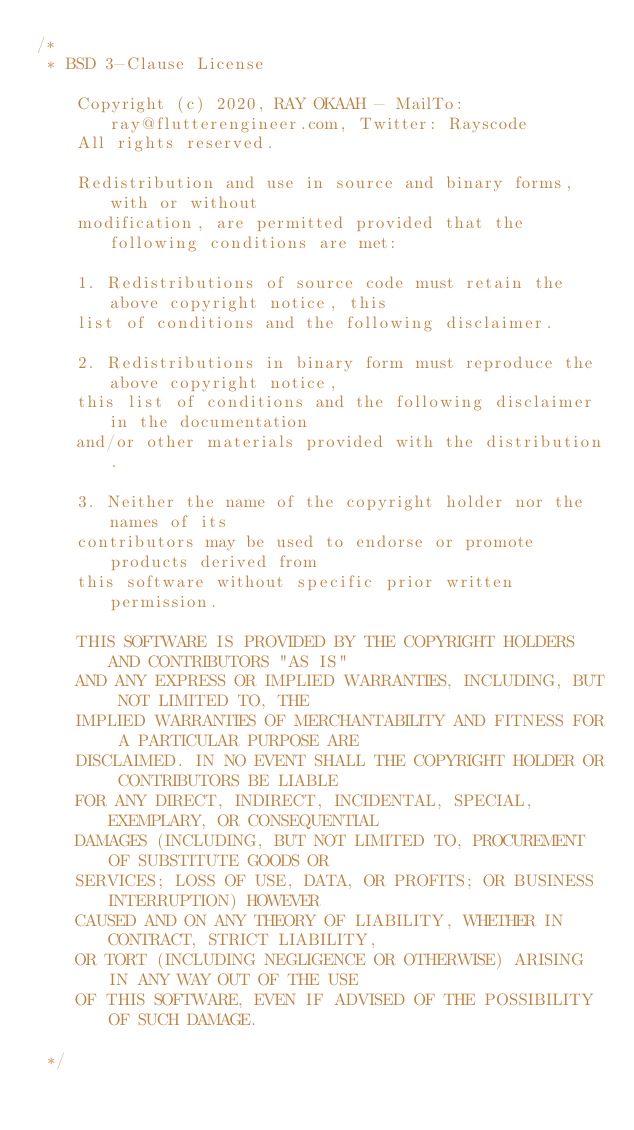<code> <loc_0><loc_0><loc_500><loc_500><_Dart_>/*
 * BSD 3-Clause License

    Copyright (c) 2020, RAY OKAAH - MailTo: ray@flutterengineer.com, Twitter: Rayscode
    All rights reserved.

    Redistribution and use in source and binary forms, with or without
    modification, are permitted provided that the following conditions are met:

    1. Redistributions of source code must retain the above copyright notice, this
    list of conditions and the following disclaimer.

    2. Redistributions in binary form must reproduce the above copyright notice,
    this list of conditions and the following disclaimer in the documentation
    and/or other materials provided with the distribution.

    3. Neither the name of the copyright holder nor the names of its
    contributors may be used to endorse or promote products derived from
    this software without specific prior written permission.

    THIS SOFTWARE IS PROVIDED BY THE COPYRIGHT HOLDERS AND CONTRIBUTORS "AS IS"
    AND ANY EXPRESS OR IMPLIED WARRANTIES, INCLUDING, BUT NOT LIMITED TO, THE
    IMPLIED WARRANTIES OF MERCHANTABILITY AND FITNESS FOR A PARTICULAR PURPOSE ARE
    DISCLAIMED. IN NO EVENT SHALL THE COPYRIGHT HOLDER OR CONTRIBUTORS BE LIABLE
    FOR ANY DIRECT, INDIRECT, INCIDENTAL, SPECIAL, EXEMPLARY, OR CONSEQUENTIAL
    DAMAGES (INCLUDING, BUT NOT LIMITED TO, PROCUREMENT OF SUBSTITUTE GOODS OR
    SERVICES; LOSS OF USE, DATA, OR PROFITS; OR BUSINESS INTERRUPTION) HOWEVER
    CAUSED AND ON ANY THEORY OF LIABILITY, WHETHER IN CONTRACT, STRICT LIABILITY,
    OR TORT (INCLUDING NEGLIGENCE OR OTHERWISE) ARISING IN ANY WAY OUT OF THE USE
    OF THIS SOFTWARE, EVEN IF ADVISED OF THE POSSIBILITY OF SUCH DAMAGE.

 */
</code> 